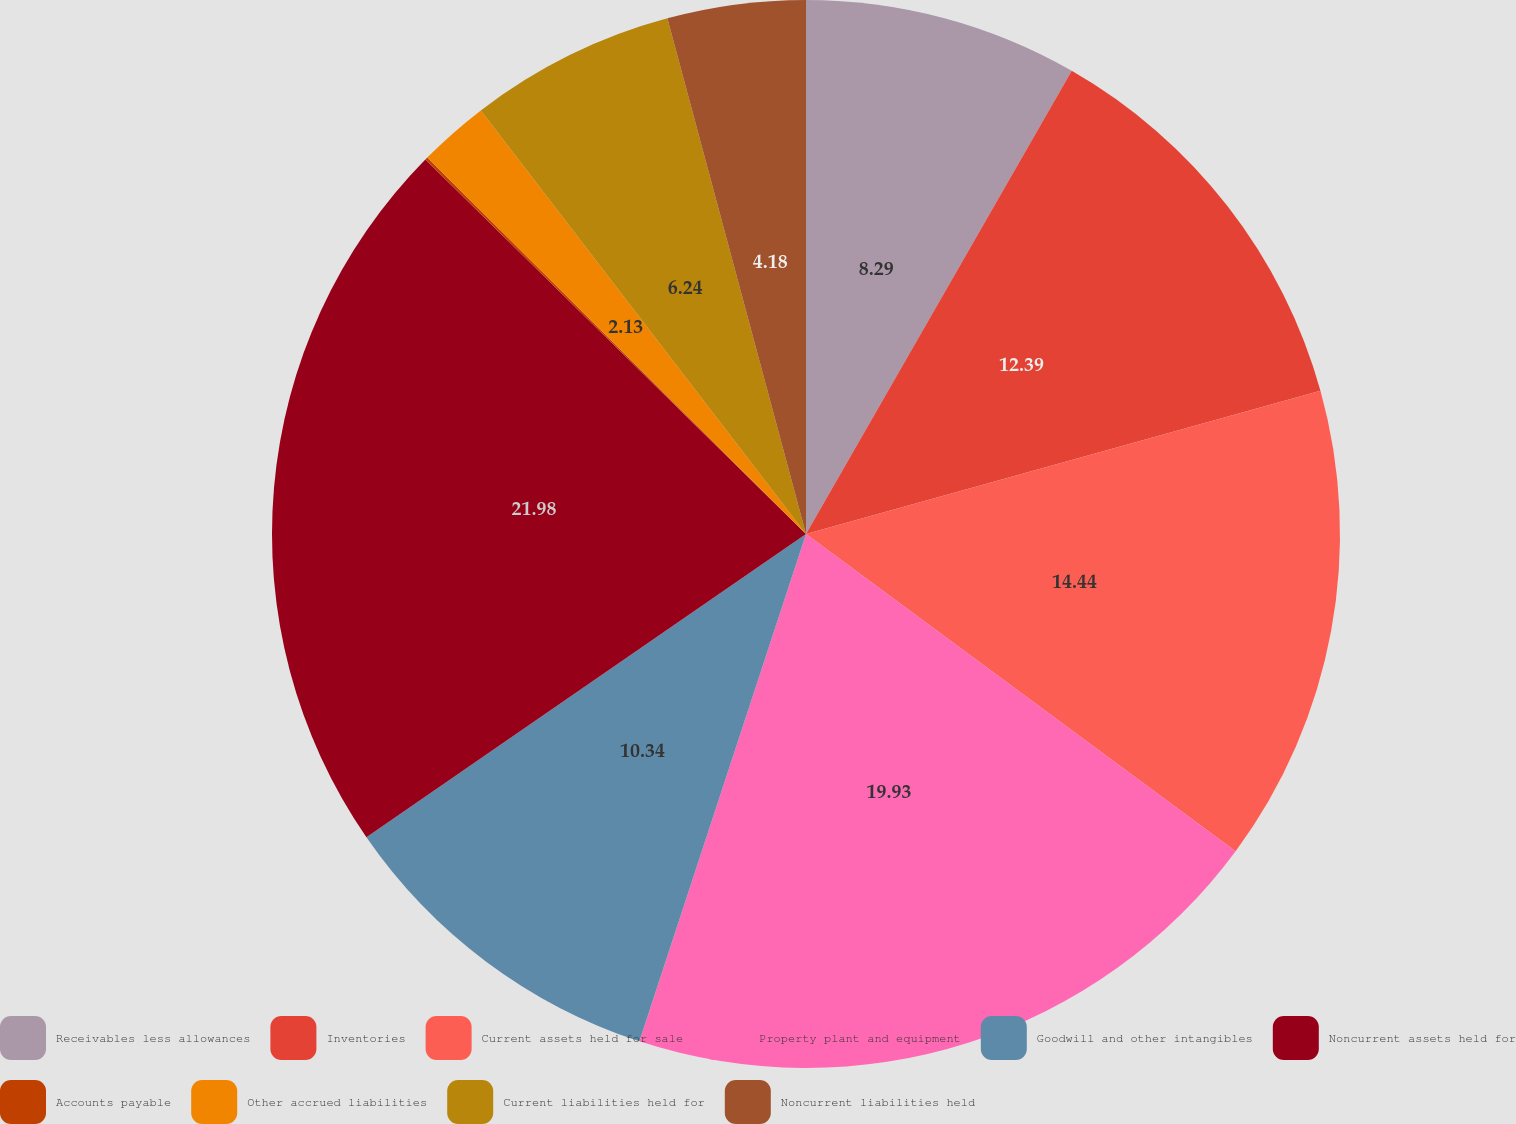Convert chart to OTSL. <chart><loc_0><loc_0><loc_500><loc_500><pie_chart><fcel>Receivables less allowances<fcel>Inventories<fcel>Current assets held for sale<fcel>Property plant and equipment<fcel>Goodwill and other intangibles<fcel>Noncurrent assets held for<fcel>Accounts payable<fcel>Other accrued liabilities<fcel>Current liabilities held for<fcel>Noncurrent liabilities held<nl><fcel>8.29%<fcel>12.39%<fcel>14.44%<fcel>19.93%<fcel>10.34%<fcel>21.98%<fcel>0.08%<fcel>2.13%<fcel>6.24%<fcel>4.18%<nl></chart> 